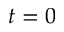<formula> <loc_0><loc_0><loc_500><loc_500>t = 0</formula> 